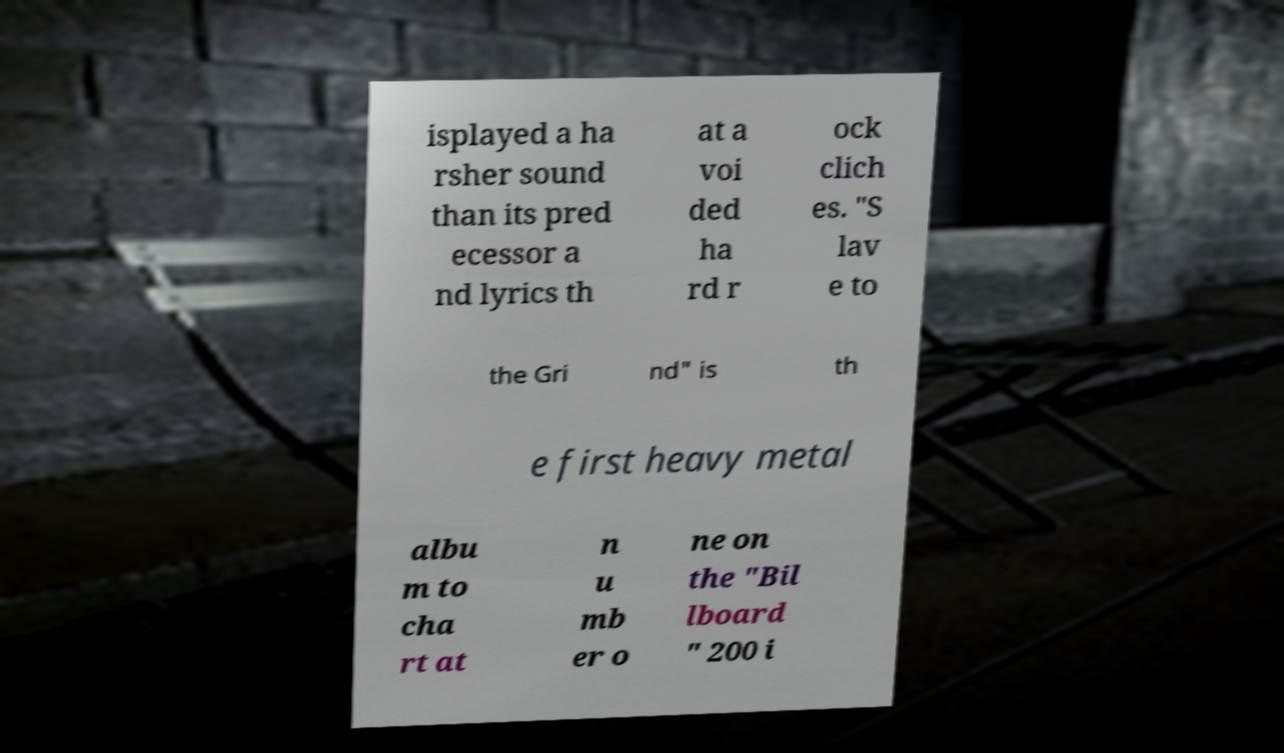I need the written content from this picture converted into text. Can you do that? isplayed a ha rsher sound than its pred ecessor a nd lyrics th at a voi ded ha rd r ock clich es. "S lav e to the Gri nd" is th e first heavy metal albu m to cha rt at n u mb er o ne on the "Bil lboard " 200 i 